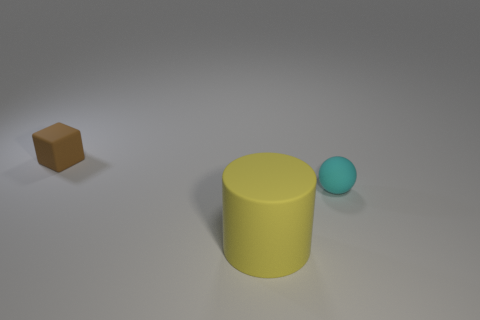Add 2 tiny brown rubber things. How many objects exist? 5 Subtract all spheres. How many objects are left? 2 Add 1 large yellow rubber things. How many large yellow rubber things exist? 2 Subtract 0 gray blocks. How many objects are left? 3 Subtract all large yellow cylinders. Subtract all brown objects. How many objects are left? 1 Add 3 big things. How many big things are left? 4 